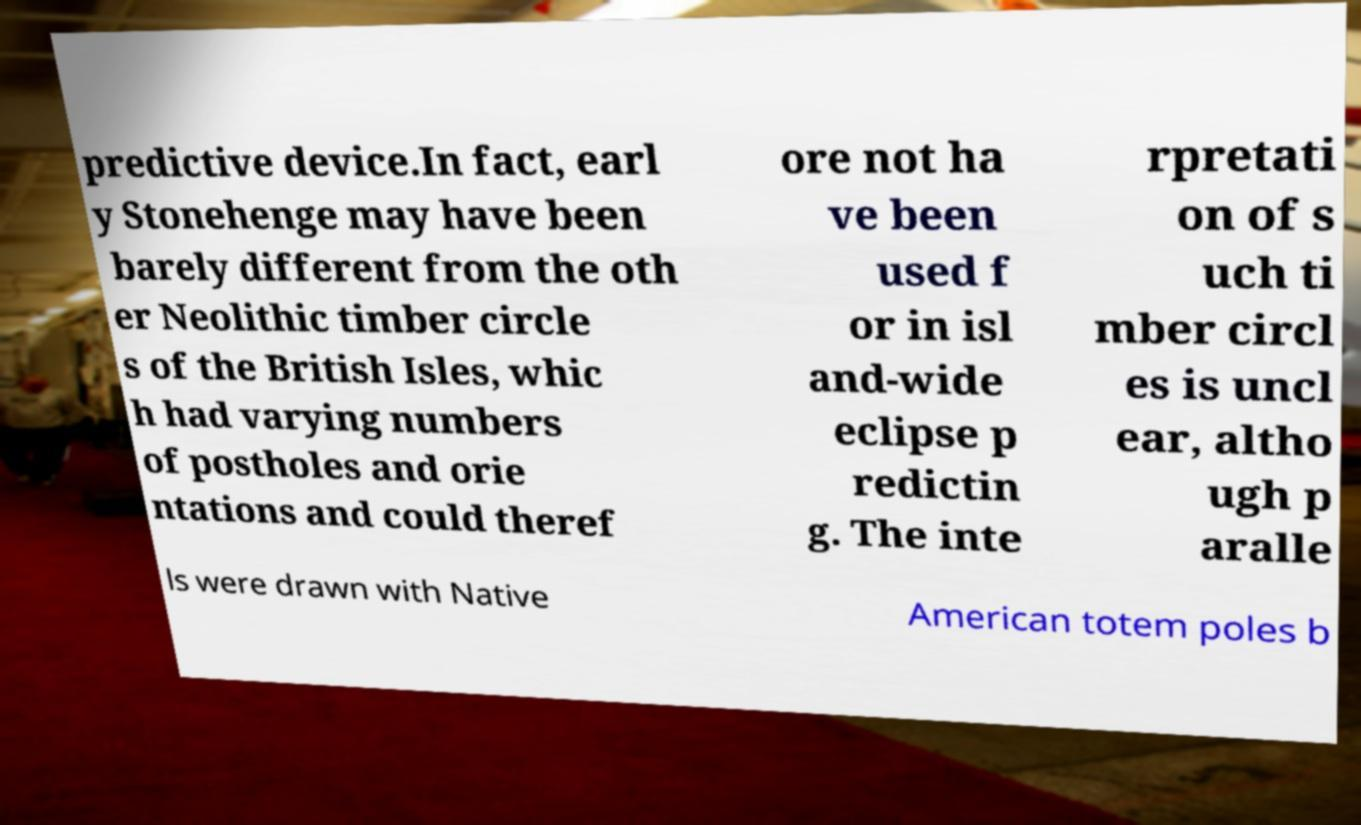I need the written content from this picture converted into text. Can you do that? predictive device.In fact, earl y Stonehenge may have been barely different from the oth er Neolithic timber circle s of the British Isles, whic h had varying numbers of postholes and orie ntations and could theref ore not ha ve been used f or in isl and-wide eclipse p redictin g. The inte rpretati on of s uch ti mber circl es is uncl ear, altho ugh p aralle ls were drawn with Native American totem poles b 